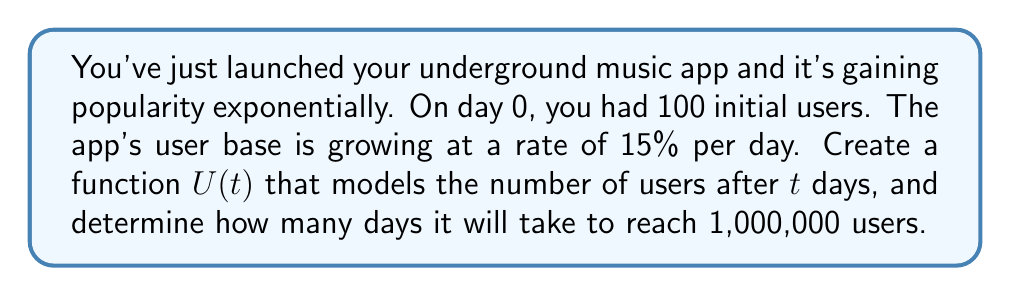Give your solution to this math problem. Let's approach this step-by-step:

1) The general form of an exponential growth function is:
   $$U(t) = U_0 \cdot (1 + r)^t$$
   Where $U_0$ is the initial number of users, $r$ is the daily growth rate, and $t$ is the number of days.

2) In this case:
   $U_0 = 100$ (initial users)
   $r = 0.15$ (15% daily growth rate)

3) Substituting these values, our function becomes:
   $$U(t) = 100 \cdot (1 + 0.15)^t = 100 \cdot (1.15)^t$$

4) To find when the app reaches 1,000,000 users, we set up the equation:
   $$1,000,000 = 100 \cdot (1.15)^t$$

5) Divide both sides by 100:
   $$10,000 = (1.15)^t$$

6) Take the natural log of both sides:
   $$\ln(10,000) = t \cdot \ln(1.15)$$

7) Solve for $t$:
   $$t = \frac{\ln(10,000)}{\ln(1.15)} \approx 39.44$$

8) Since we can't have a fractional day, we round up to the next whole day.
Answer: 40 days 